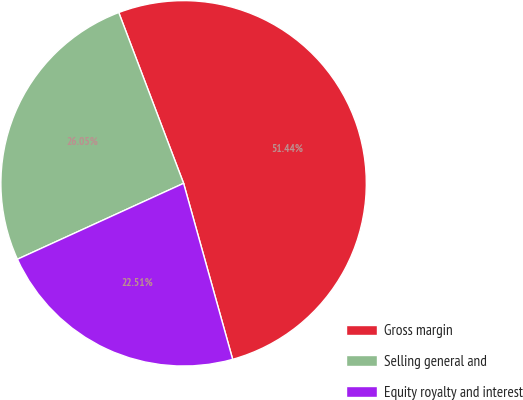Convert chart to OTSL. <chart><loc_0><loc_0><loc_500><loc_500><pie_chart><fcel>Gross margin<fcel>Selling general and<fcel>Equity royalty and interest<nl><fcel>51.45%<fcel>26.05%<fcel>22.51%<nl></chart> 